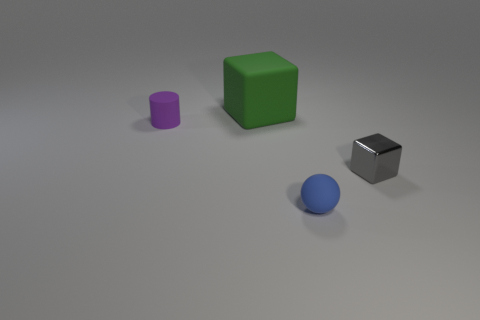Are there any other things that have the same material as the small gray thing?
Your answer should be very brief. No. There is a large object that is the same shape as the tiny metal thing; what is its color?
Give a very brief answer. Green. Is there anything else of the same color as the tiny cube?
Your answer should be compact. No. There is a block in front of the small purple thing; how big is it?
Your answer should be very brief. Small. What number of other things are there of the same material as the gray block
Your answer should be compact. 0. Is the number of big gray cylinders greater than the number of small gray shiny objects?
Your response must be concise. No. The big thing has what color?
Provide a succinct answer. Green. There is a tiny rubber object that is in front of the matte cylinder; are there any big objects right of it?
Give a very brief answer. No. What is the shape of the tiny matte thing to the right of the tiny matte thing behind the gray object?
Your answer should be compact. Sphere. Are there fewer small yellow metal spheres than big green blocks?
Offer a terse response. Yes. 